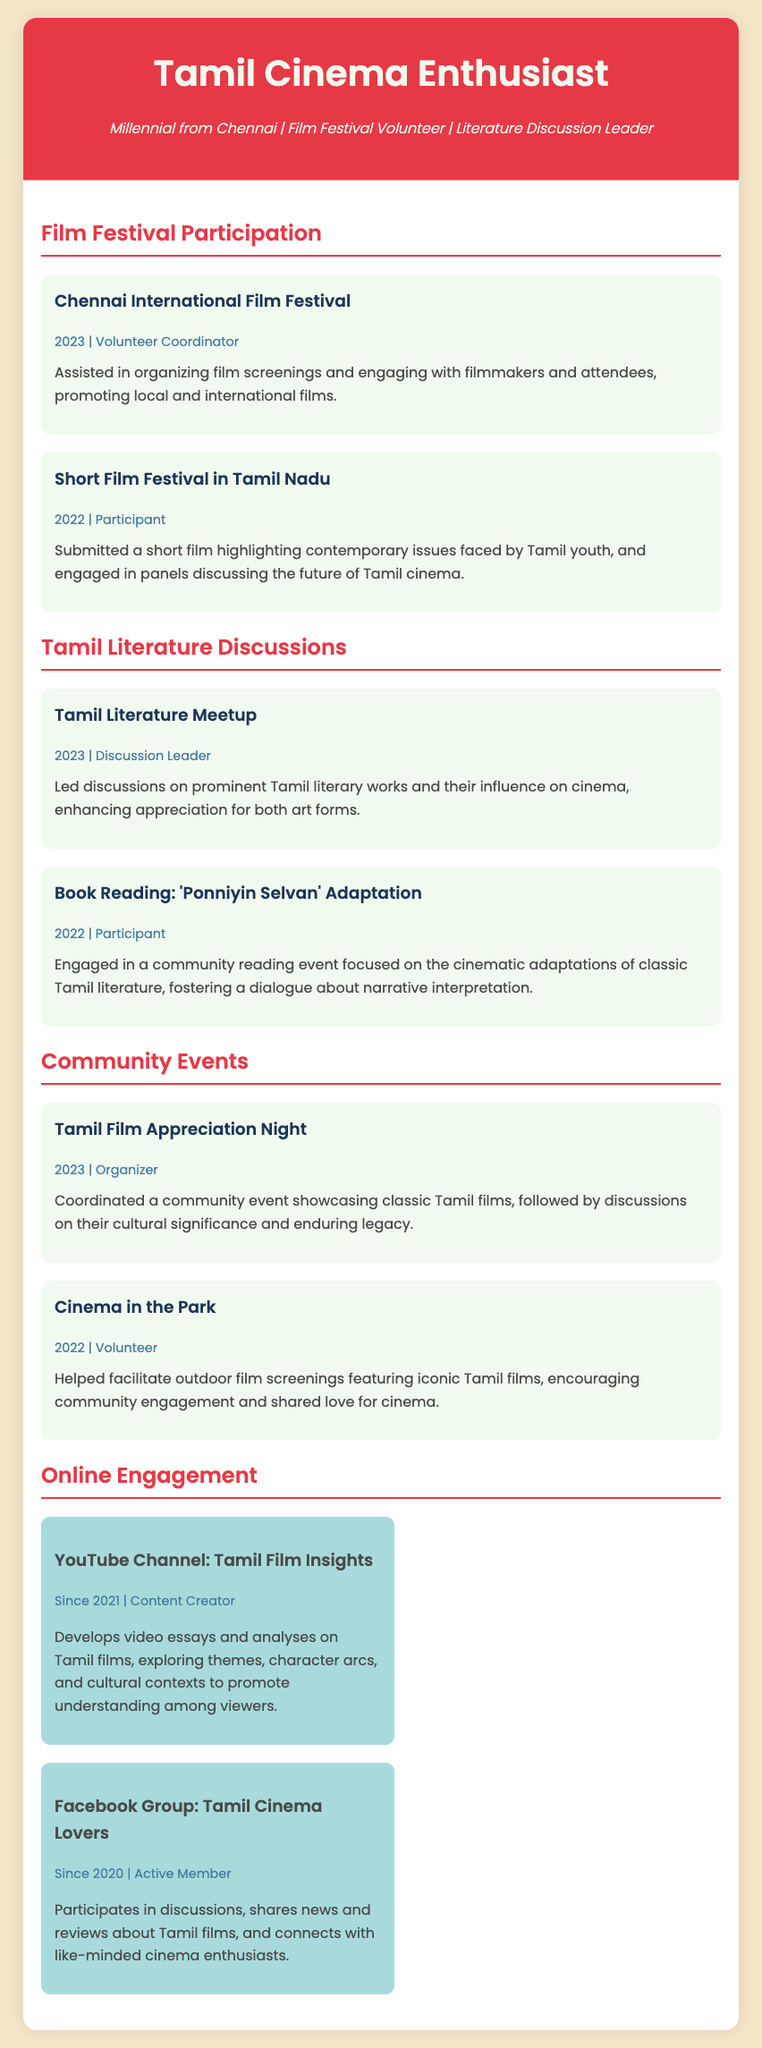what is the title of the CV? The title is located at the top of the document and indicates the theme of the CV.
Answer: Tamil Cinema Enthusiast who coordinated the Chennai International Film Festival in 2023? The document specifies the role and the name of the person in charge of this event.
Answer: Volunteer Coordinator what year did the Tamil Literature Meetup take place? The date is listed in the meta-information about the event in the document.
Answer: 2023 what type of event was the "Cinema in the Park"? The event type is described in the community events section of the document.
Answer: Volunteer what online platform features the content creator's YouTube channel? The platform is explicitly mentioned in the online engagement section.
Answer: YouTube Channel: Tamil Film Insights how many community events are detailed in the document? Counting the events listed under the community events section provides this information.
Answer: 2 what is the primary focus of the "Tamil Film Appreciation Night"? The focus is described in the event segment outlining what was showcased during this event.
Answer: Classic Tamil films who is an active member of the Facebook group? The role of the person in the group is provided in the online engagement section of the document.
Answer: Active Member what was the participant's role in the Short Film Festival in Tamil Nadu? The role is noted in the details about the participant's involvement in this festival.
Answer: Participant 